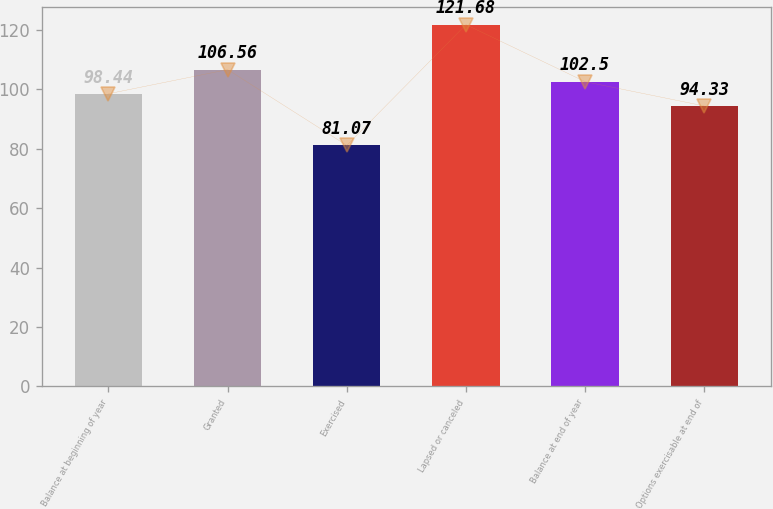<chart> <loc_0><loc_0><loc_500><loc_500><bar_chart><fcel>Balance at beginning of year<fcel>Granted<fcel>Exercised<fcel>Lapsed or canceled<fcel>Balance at end of year<fcel>Options exercisable at end of<nl><fcel>98.44<fcel>106.56<fcel>81.07<fcel>121.68<fcel>102.5<fcel>94.33<nl></chart> 